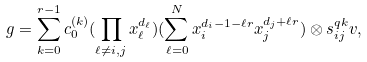<formula> <loc_0><loc_0><loc_500><loc_500>g = \sum _ { k = 0 } ^ { r - 1 } c _ { 0 } ^ { ( k ) } ( \prod _ { \ell \ne i , j } x _ { \ell } ^ { d _ { \ell } } ) ( \sum _ { \ell = 0 } ^ { N } x _ { i } ^ { d _ { i } - 1 - \ell r } x _ { j } ^ { d _ { j } + \ell r } ) \otimes s ^ { q k } _ { i j } v ,</formula> 